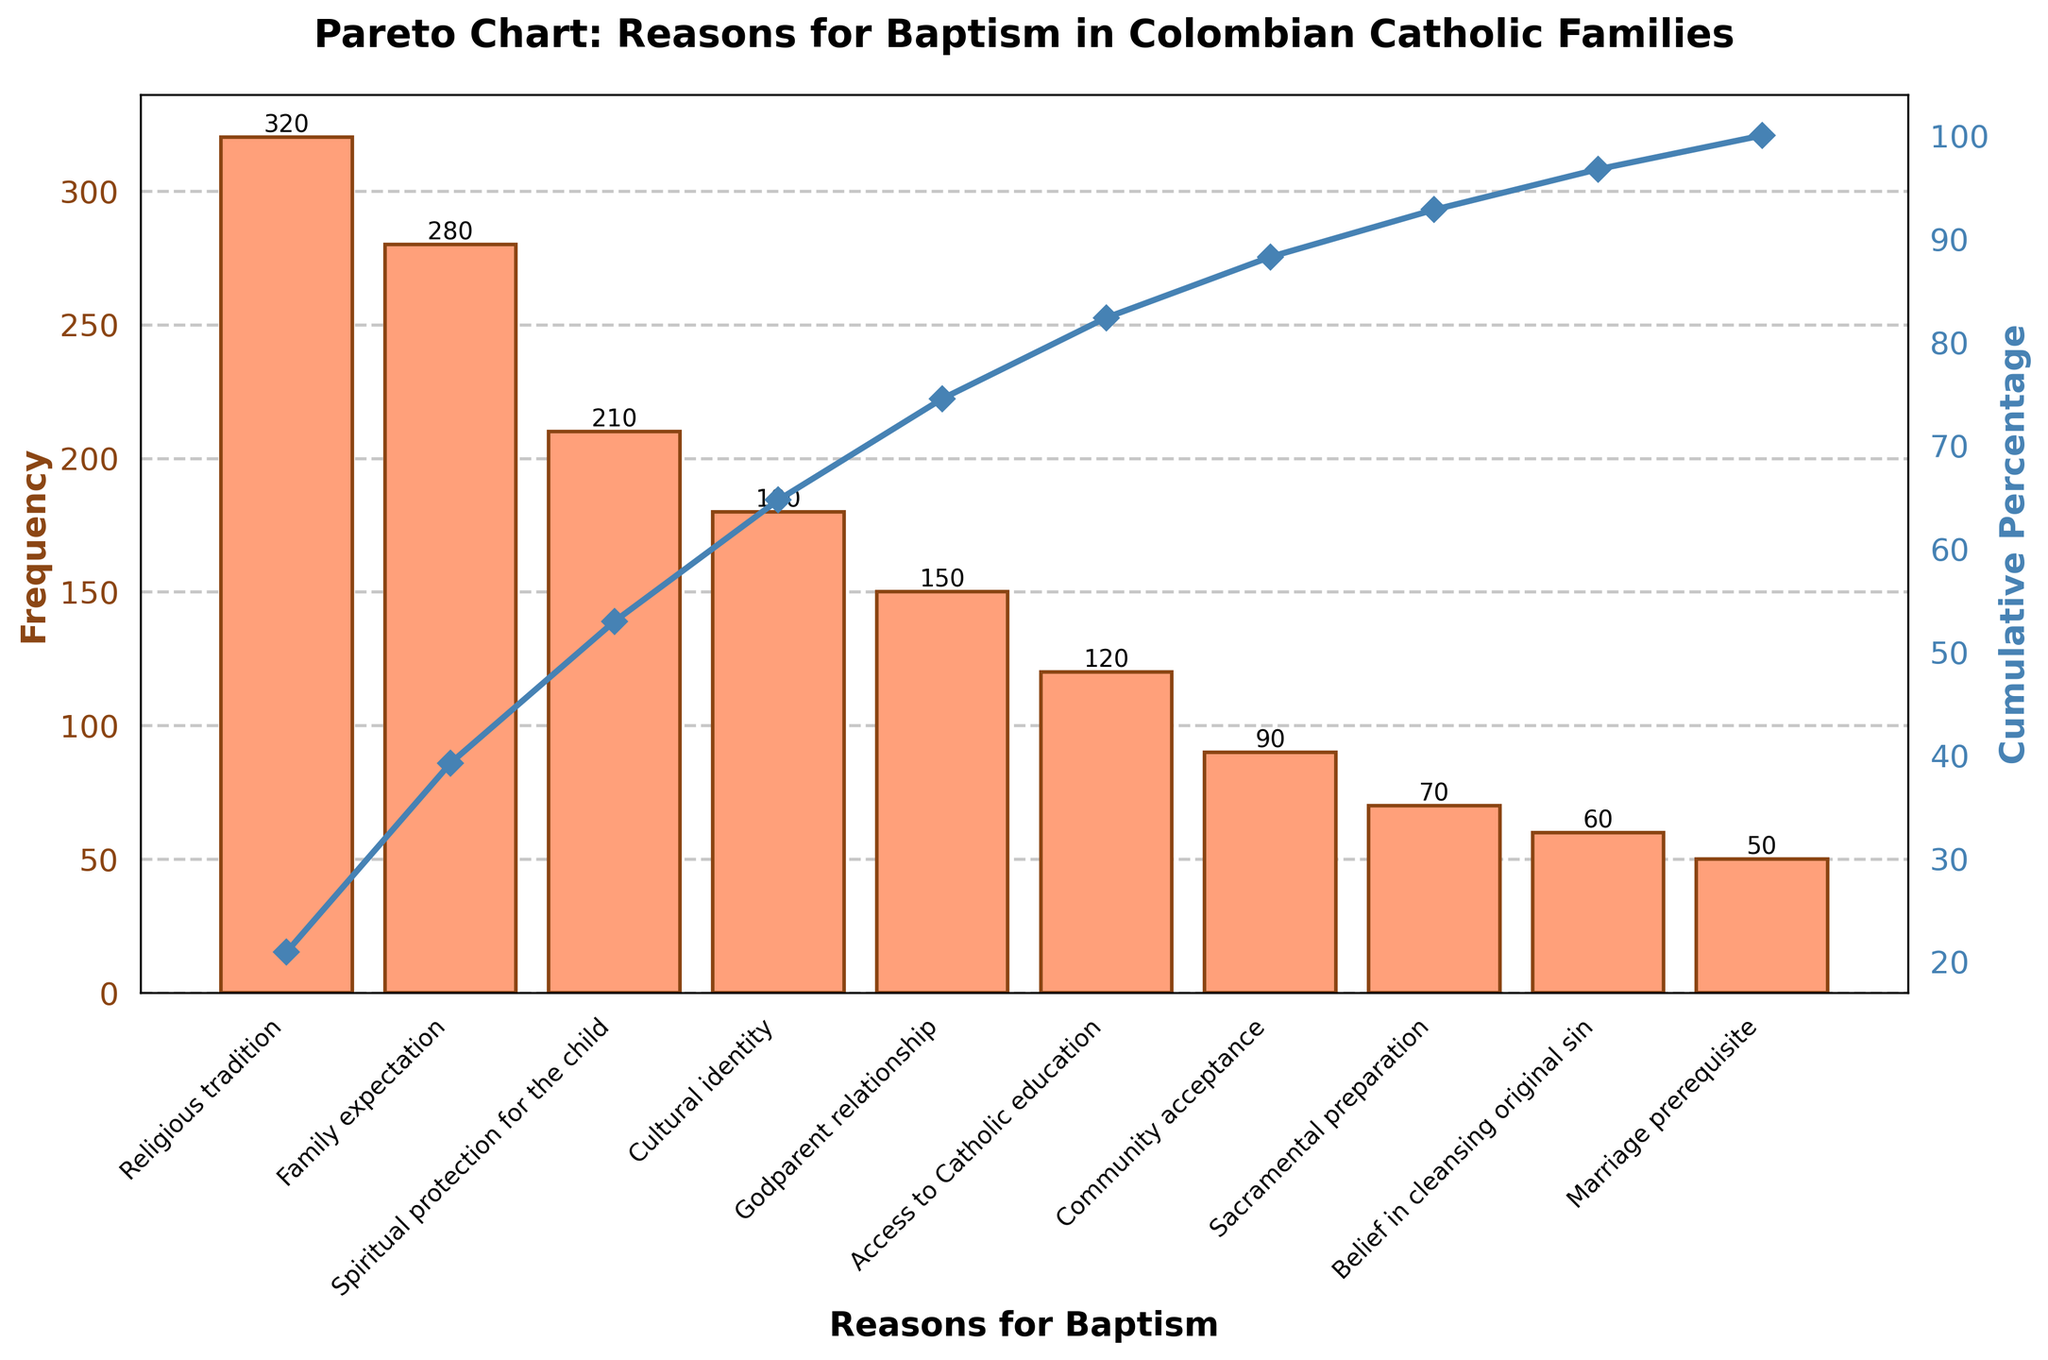How many reasons are listed in the chart? The number of reasons is equal to the number of bars in the chart. Count each bar from the figure, including 'Religious tradition' to 'Marriage prerequisite'.
Answer: 10 What is the most common reason for baptism among Colombian Catholic families? The most common reason corresponds to the tallest bar in the chart.
Answer: Religious tradition Which reasons contribute to more than 70% of the total frequency? Look at the cumulative percentage line on the plot and identify the reasons until the cumulative percentage exceeds 70%. List these reasons.
Answer: Religious tradition, Family expectation, Spiritual protection for the child How much higher is the frequency for 'Family expectation' compared to 'Marriage prerequisite'? Subtract the frequency of 'Marriage prerequisite' from the frequency of 'Family expectation': 280 - 50 = 230
Answer: 230 What cumulative percentage does 'Cultural identity' contribute to? Find 'Cultural identity' on the x-axis and trace it up to the cumulative percentage line on the secondary y-axis to find its value.
Answer: 73% Are there more reasons with a frequency above 100 or below 100? Count the number of bars where the frequency is above 100 and compare it to the count of bars where the frequency is below 100. There are 6 bars above and 4 bars below.
Answer: Above 100 How does the frequency of 'Godparent relationship' compare to 'Community acceptance'? Check the heights of the 'Godparent relationship' and 'Community acceptance' bars, and note the values: 150 and 90, respectively. 'Godparent relationship' is higher than 'Community acceptance' by 60.
Answer: Higher by 60 Which reason is closest to the median frequency value? Order the bars by frequency and find the middle value. The median in this 10-element list would be the average of the 5th and 6th frequencies: (150+120)/2=135. Then find the closest bar to this median value.
Answer: Godparent relationship What is the cumulative percentage after including 'Access to Catholic education'? Identify 'Access to Catholic education' and check its cumulative percentage value from the secondary y-axis.
Answer: 89% How does the total frequency of the top three reasons compare to the combined frequency of the bottom three reasons? Sum the frequencies of the top three reasons (320 + 280 + 210 = 810) and the bottom three reasons (70 + 60 + 50 = 180), and compare them.
Answer: 810 vs. 180 